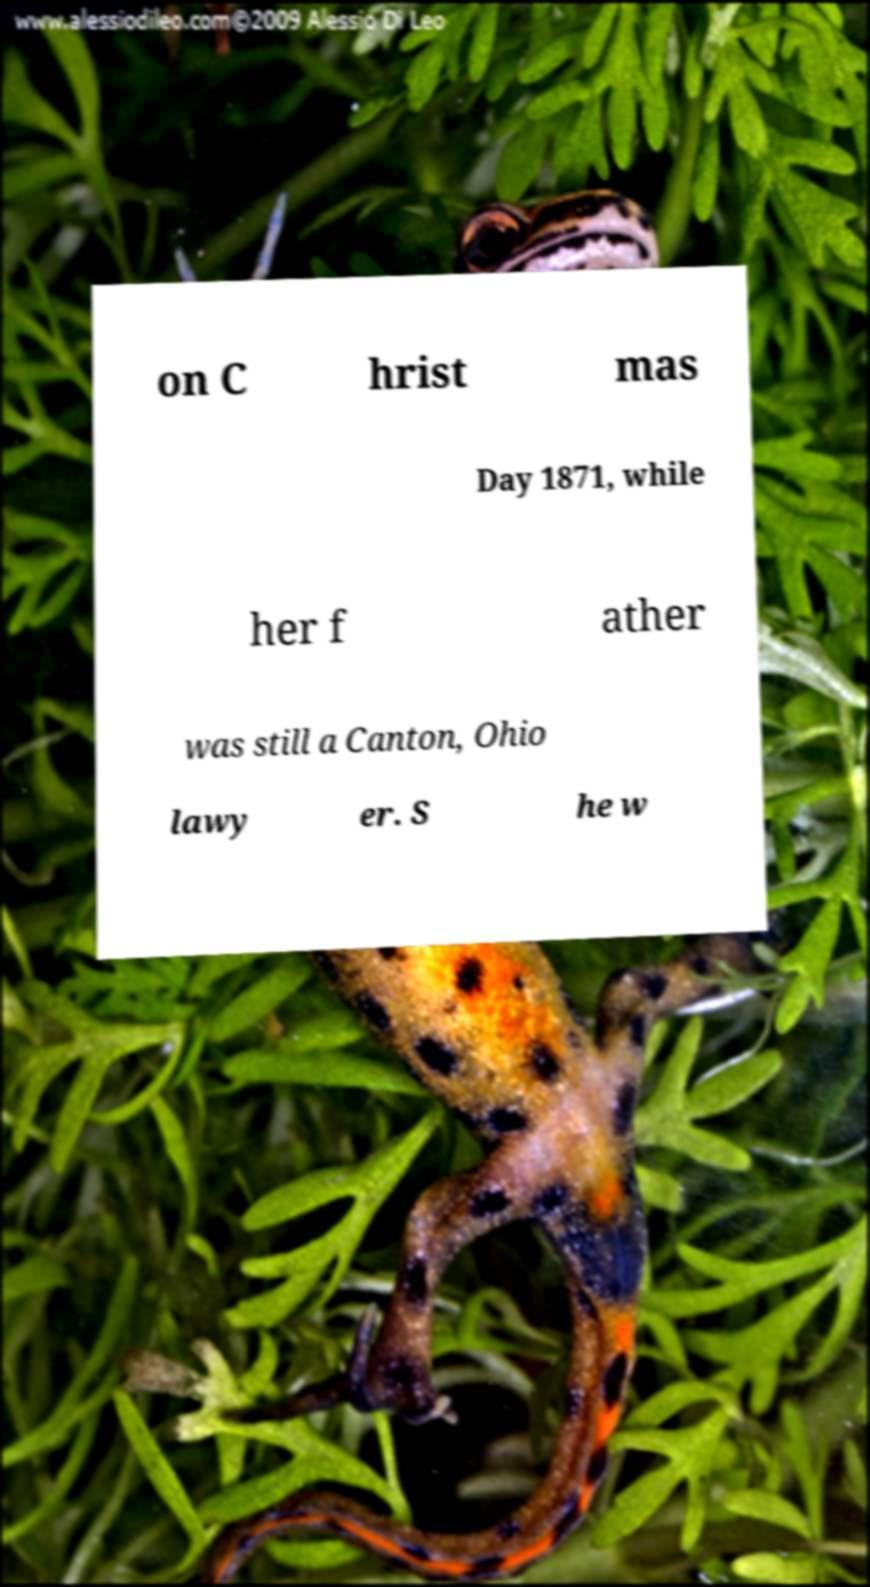What messages or text are displayed in this image? I need them in a readable, typed format. on C hrist mas Day 1871, while her f ather was still a Canton, Ohio lawy er. S he w 